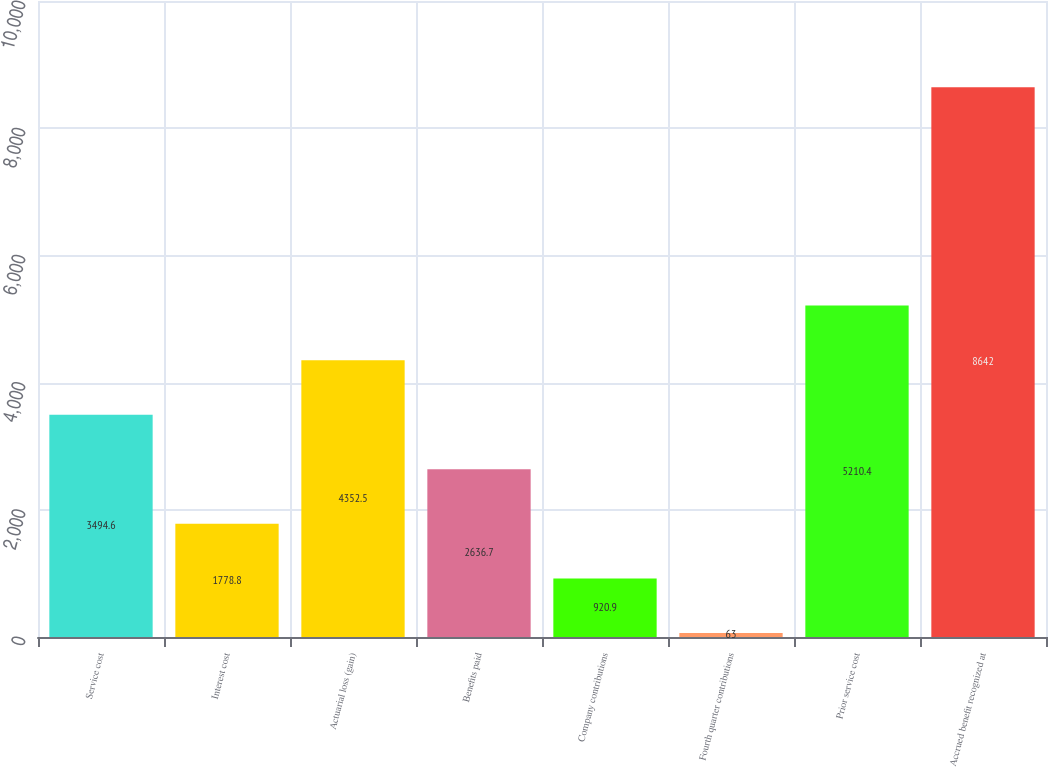<chart> <loc_0><loc_0><loc_500><loc_500><bar_chart><fcel>Service cost<fcel>Interest cost<fcel>Actuarial loss (gain)<fcel>Benefits paid<fcel>Company contributions<fcel>Fourth quarter contributions<fcel>Prior service cost<fcel>Accrued benefit recognized at<nl><fcel>3494.6<fcel>1778.8<fcel>4352.5<fcel>2636.7<fcel>920.9<fcel>63<fcel>5210.4<fcel>8642<nl></chart> 